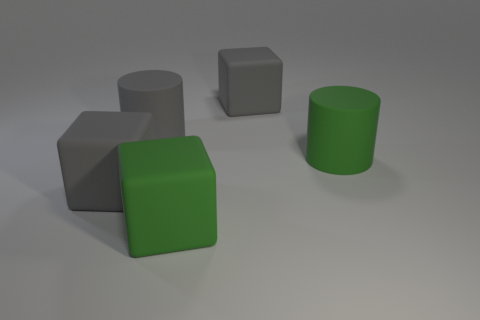How big is the gray rubber cube in front of the green matte thing behind the green cube?
Your answer should be compact. Large. Are there more big things that are to the left of the big gray cylinder than large rubber cylinders in front of the big green matte cylinder?
Give a very brief answer. Yes. How many blocks are large purple rubber things or large green rubber things?
Keep it short and to the point. 1. How many things are either large green cubes or big matte things that are on the left side of the large green rubber cylinder?
Your answer should be very brief. 4. What is the size of the matte thing that is both in front of the large green cylinder and behind the large green block?
Offer a very short reply. Large. There is a green matte cylinder; are there any gray cylinders in front of it?
Offer a very short reply. No. Are there any things left of the cylinder that is in front of the large gray rubber cylinder?
Offer a terse response. Yes. Are there an equal number of things in front of the green cylinder and large matte blocks that are on the right side of the gray rubber cylinder?
Provide a succinct answer. Yes. There is another large cylinder that is made of the same material as the large gray cylinder; what color is it?
Your answer should be compact. Green. Is there a blue cube that has the same material as the green block?
Provide a short and direct response. No. 